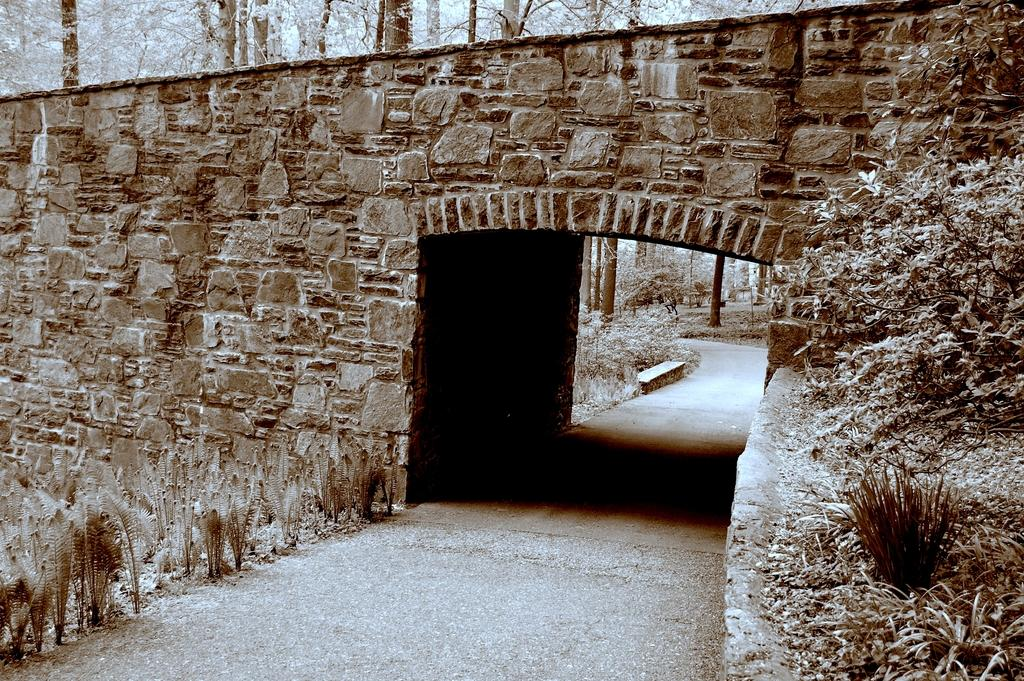What type of vegetation can be seen in the image? There are plants and trees in the image. What type of ground surface is visible in the image? There is grass in the image. What type of pathway is present in the image? There is a road in the image. What is the overall color tone of the image? The image has a brown color tone. What type of camp can be seen in the image? There is no camp present in the image. What type of plants are being cooked in the image? There is no cooking or plants being cooked in the image. 